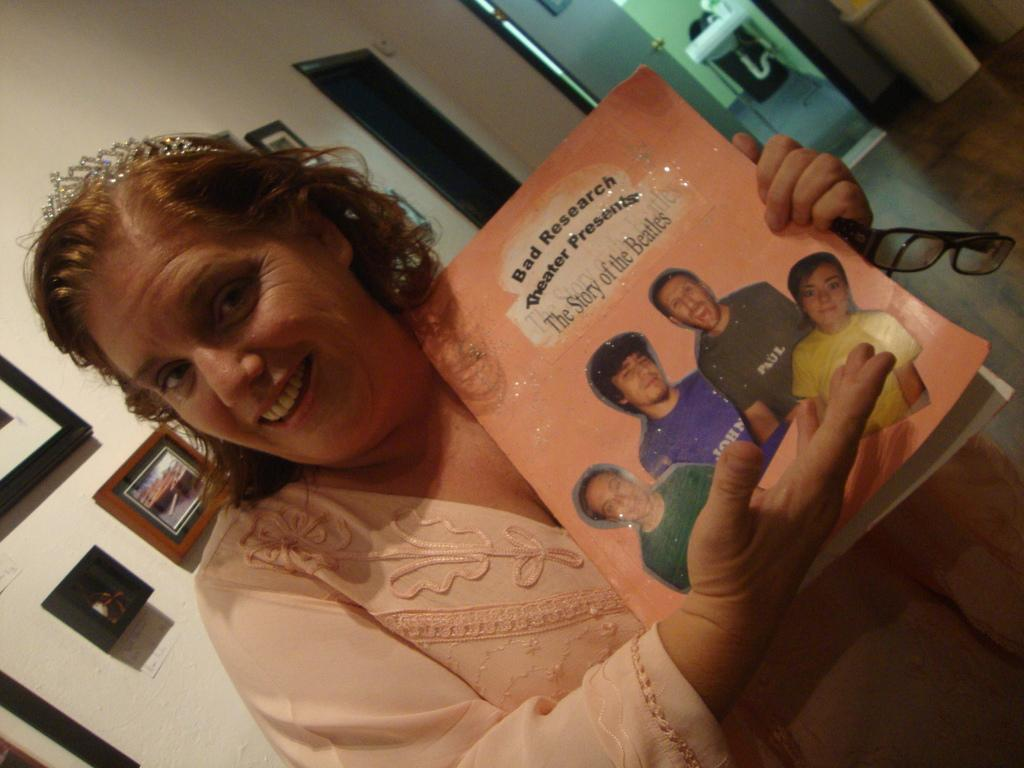What is the woman in the image holding? The woman is holding a book. What is the woman wearing on her face? The woman is wearing spectacles. What expression does the woman have in the image? The woman is smiling. What can be seen in the background of the image? There are frames, a wall, doors, a pipe, and a sink in the background of the image. What type of pies can be seen on the table in the image? There is no table or pies present in the image. What record is the woman listening to in the image? There is no record or music player present in the image. 